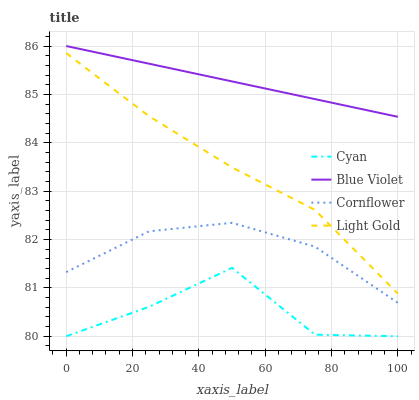Does Cyan have the minimum area under the curve?
Answer yes or no. Yes. Does Blue Violet have the maximum area under the curve?
Answer yes or no. Yes. Does Light Gold have the minimum area under the curve?
Answer yes or no. No. Does Light Gold have the maximum area under the curve?
Answer yes or no. No. Is Blue Violet the smoothest?
Answer yes or no. Yes. Is Cyan the roughest?
Answer yes or no. Yes. Is Light Gold the smoothest?
Answer yes or no. No. Is Light Gold the roughest?
Answer yes or no. No. Does Cyan have the lowest value?
Answer yes or no. Yes. Does Light Gold have the lowest value?
Answer yes or no. No. Does Blue Violet have the highest value?
Answer yes or no. Yes. Does Light Gold have the highest value?
Answer yes or no. No. Is Cyan less than Light Gold?
Answer yes or no. Yes. Is Blue Violet greater than Cyan?
Answer yes or no. Yes. Does Cyan intersect Light Gold?
Answer yes or no. No. 